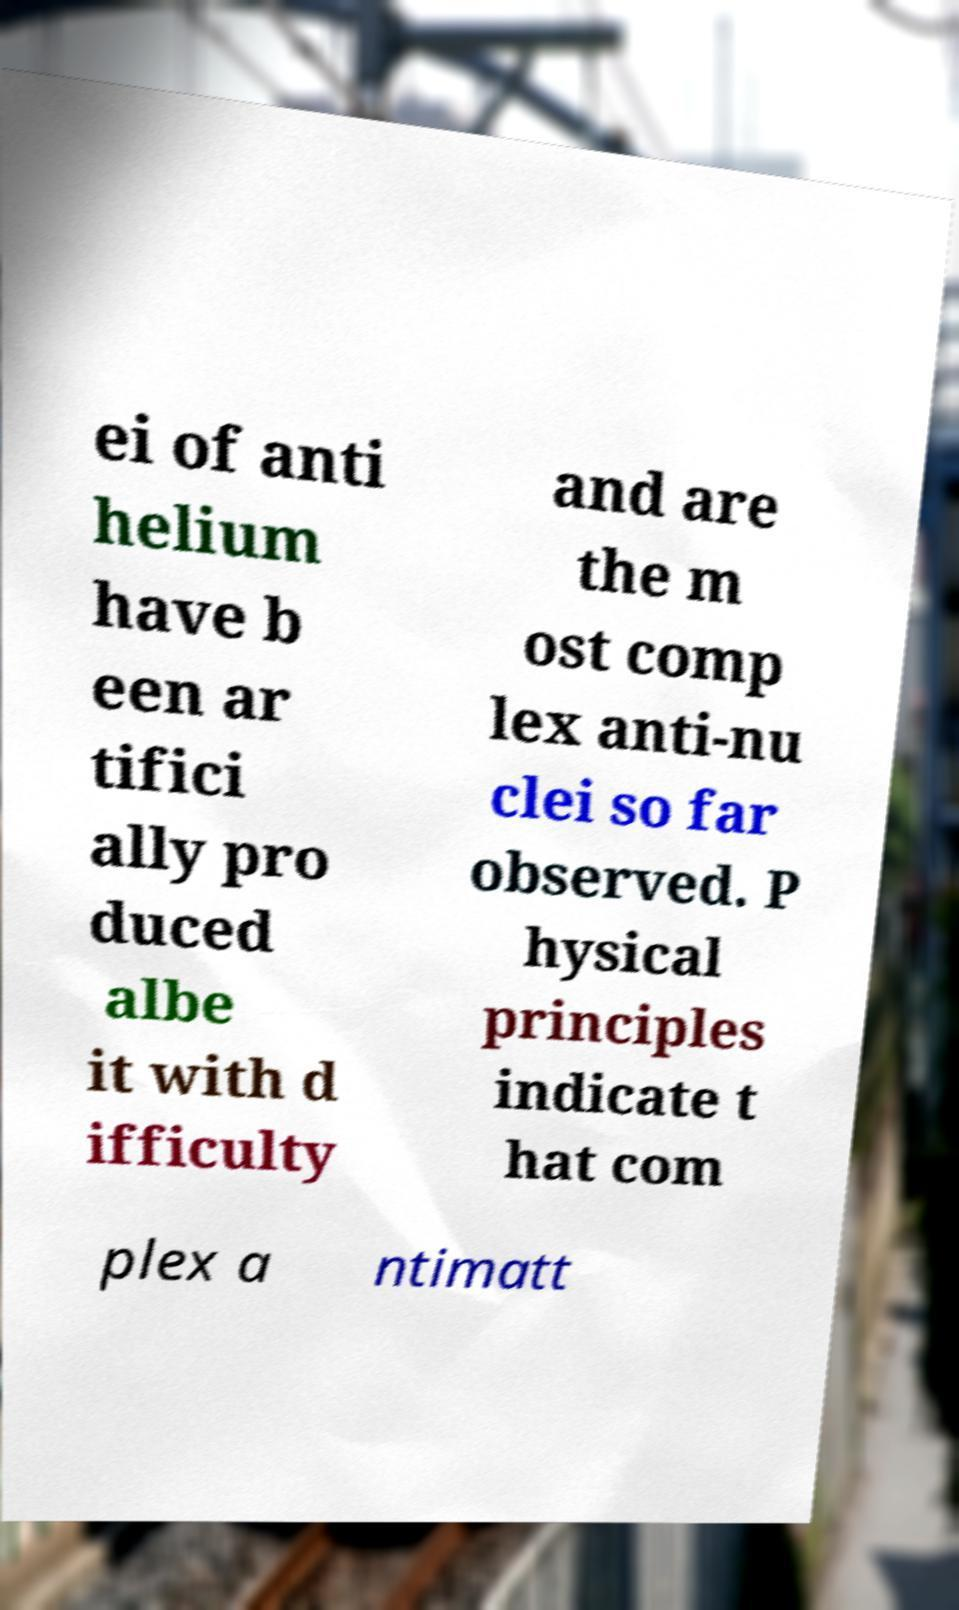Could you assist in decoding the text presented in this image and type it out clearly? ei of anti helium have b een ar tifici ally pro duced albe it with d ifficulty and are the m ost comp lex anti-nu clei so far observed. P hysical principles indicate t hat com plex a ntimatt 